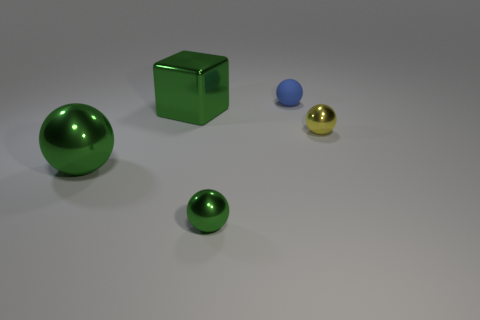Add 5 blue objects. How many objects exist? 10 Subtract all blocks. How many objects are left? 4 Add 2 yellow balls. How many yellow balls exist? 3 Subtract 0 yellow cylinders. How many objects are left? 5 Subtract all blue matte balls. Subtract all big shiny balls. How many objects are left? 3 Add 5 rubber objects. How many rubber objects are left? 6 